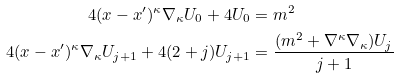<formula> <loc_0><loc_0><loc_500><loc_500>4 ( x - x ^ { \prime } ) ^ { \kappa } \nabla _ { \kappa } U _ { 0 } + 4 U _ { 0 } & = m ^ { 2 } \\ 4 ( x - x ^ { \prime } ) ^ { \kappa } \nabla _ { \kappa } U _ { j + 1 } + 4 ( 2 + j ) U _ { j + 1 } & = \frac { ( m ^ { 2 } + \nabla ^ { \kappa } \nabla _ { \kappa } ) U _ { j } } { j + 1 }</formula> 